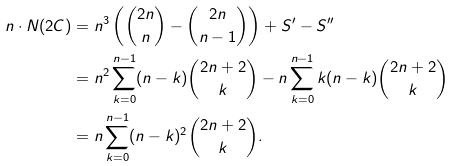Convert formula to latex. <formula><loc_0><loc_0><loc_500><loc_500>n \cdot N ( 2 C ) & = n ^ { 3 } \left ( { 2 n \choose n } - { 2 n \choose n - 1 } \right ) + S ^ { \prime } - S ^ { \prime \prime } \\ & = n ^ { 2 } \sum _ { k = 0 } ^ { n - 1 } ( n - k ) { 2 n + 2 \choose k } - n \sum _ { k = 0 } ^ { n - 1 } k ( n - k ) { 2 n + 2 \choose k } \\ & = n \sum _ { k = 0 } ^ { n - 1 } ( n - k ) ^ { 2 } { 2 n + 2 \choose k } .</formula> 